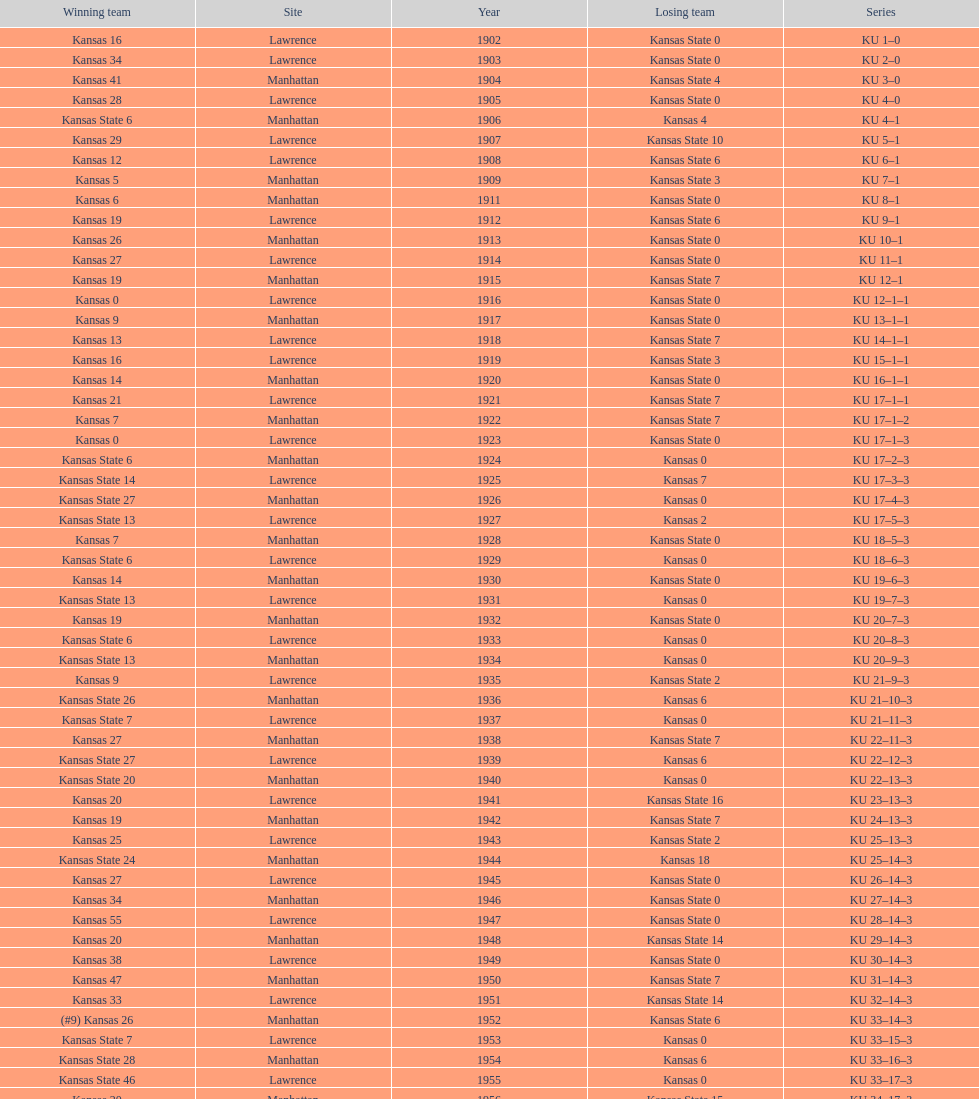How many times did kansas beat kansas state before 1910? 7. 